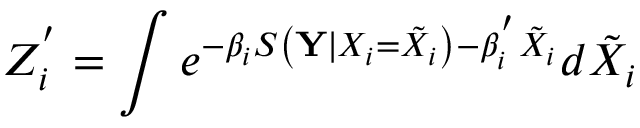<formula> <loc_0><loc_0><loc_500><loc_500>Z _ { i } ^ { ^ { \prime } } = \int e ^ { - \beta _ { i } S \left ( { Y } | { X } _ { i } = \tilde { X } _ { i } \right ) - \beta _ { i } ^ { ^ { \prime } } \tilde { X } _ { i } } d \tilde { X } _ { i }</formula> 